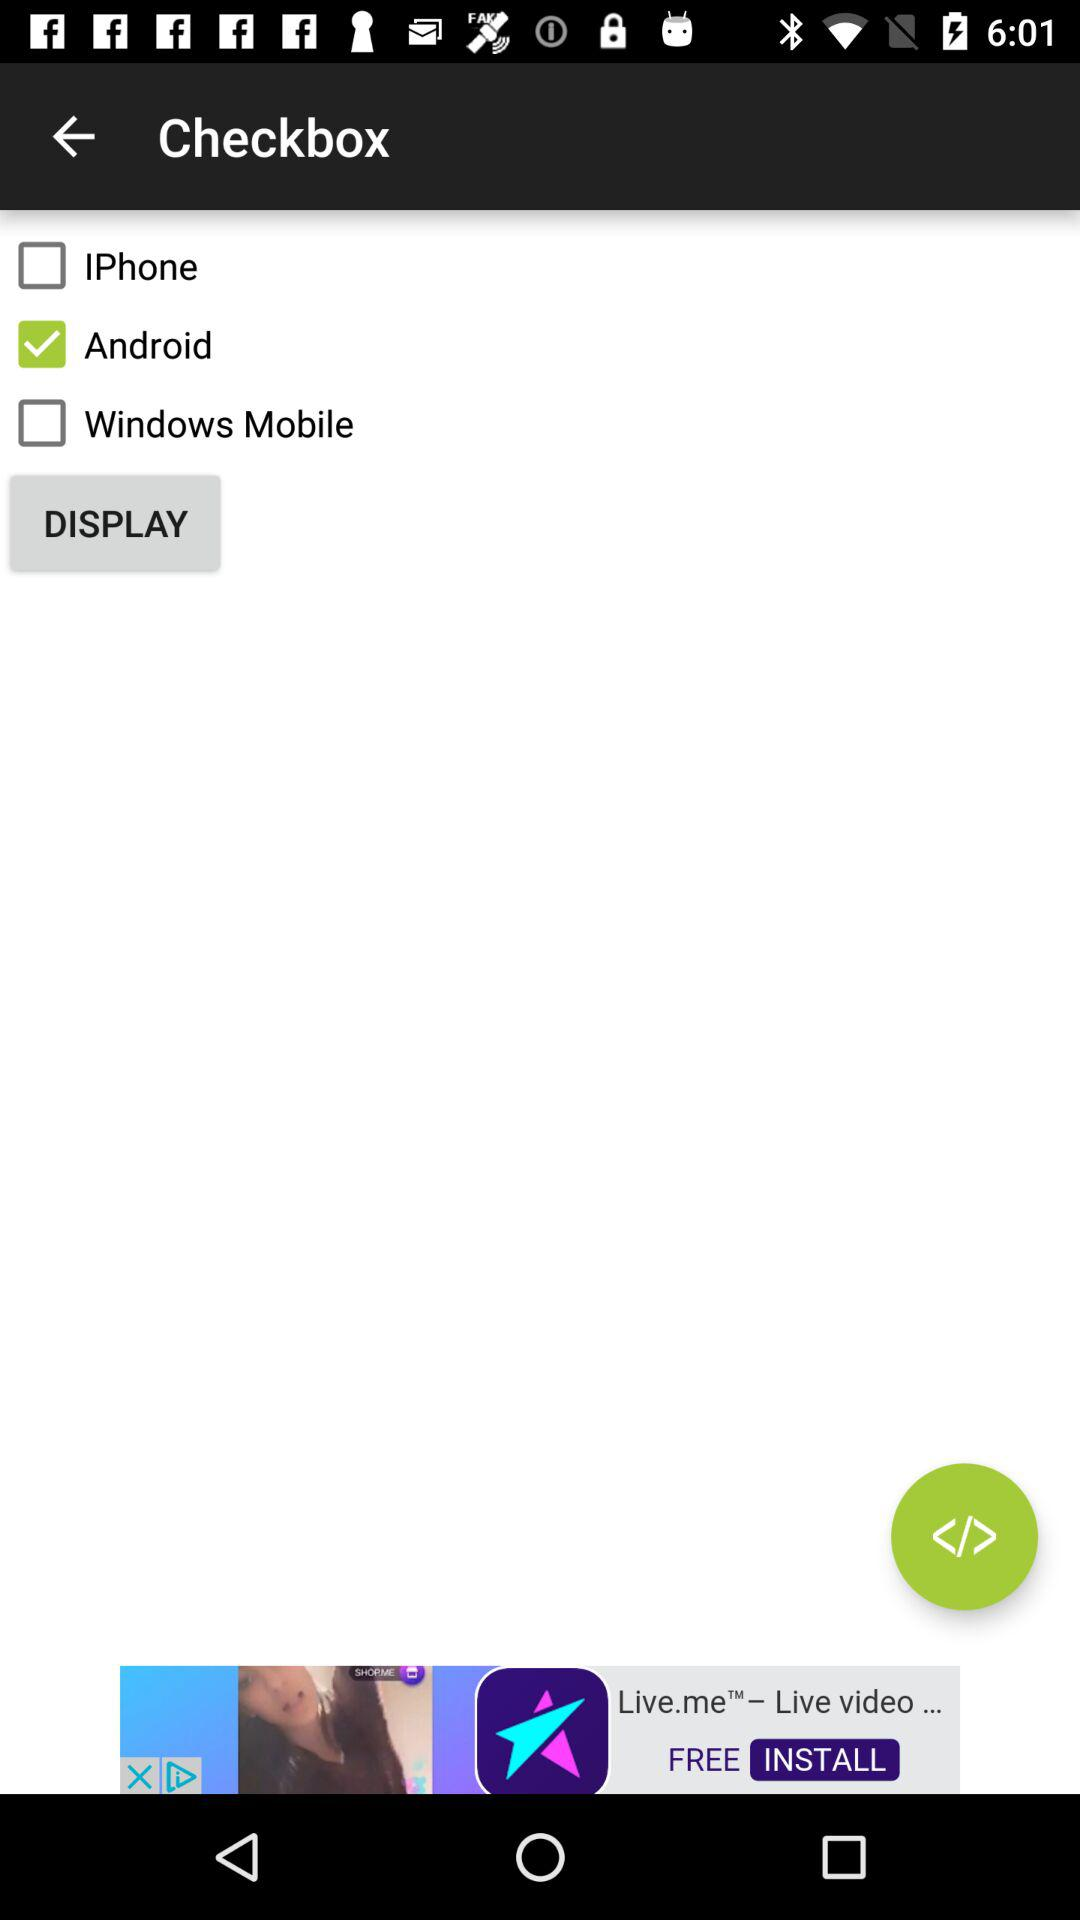Can you comment on the design or layout presented in the image? The image depicts a simple user interface with a clear layout that lists options in the form of checkboxes. It's a minimalist design that allows for easy selection between multiple choices.  Do the checkboxes indicate any sort of preference or ranking? The image doesn't provide context that indicates a preference or ranking. The checked box next to 'Android' simply shows a selection has been made, without implying any superiority over the other options. 